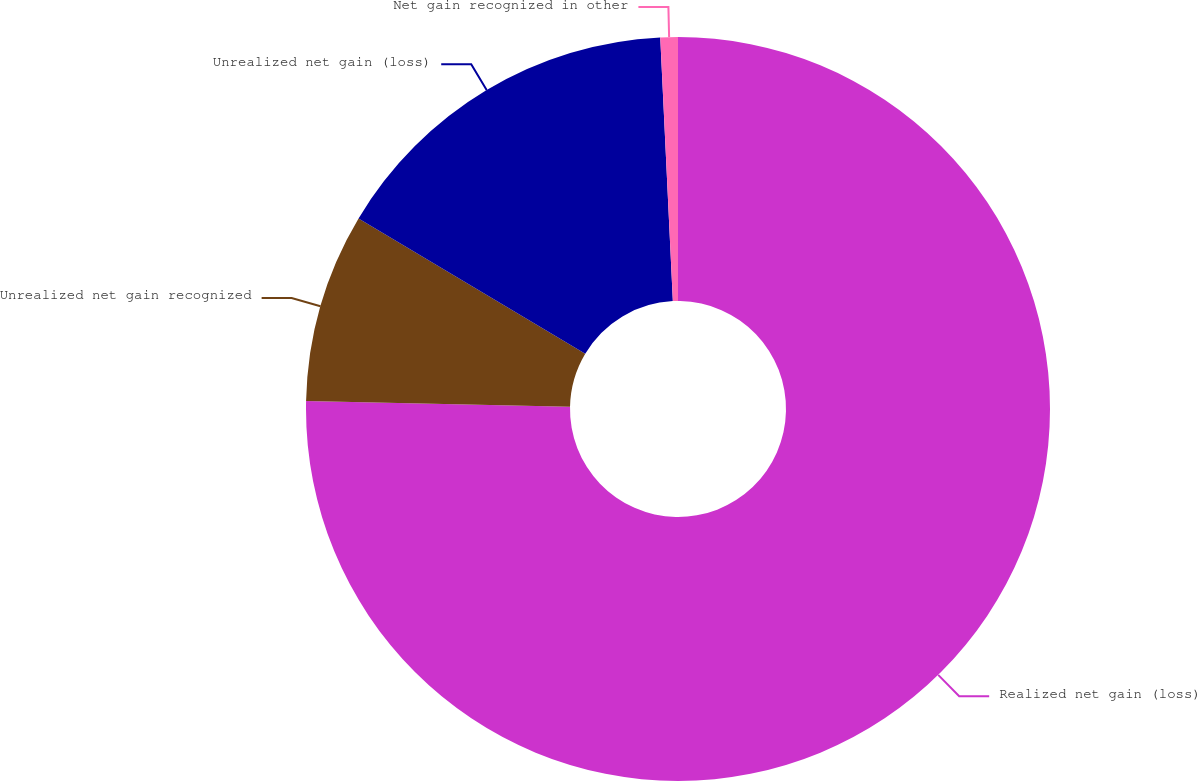<chart> <loc_0><loc_0><loc_500><loc_500><pie_chart><fcel>Realized net gain (loss)<fcel>Unrealized net gain recognized<fcel>Unrealized net gain (loss)<fcel>Net gain recognized in other<nl><fcel>75.35%<fcel>8.22%<fcel>15.68%<fcel>0.76%<nl></chart> 